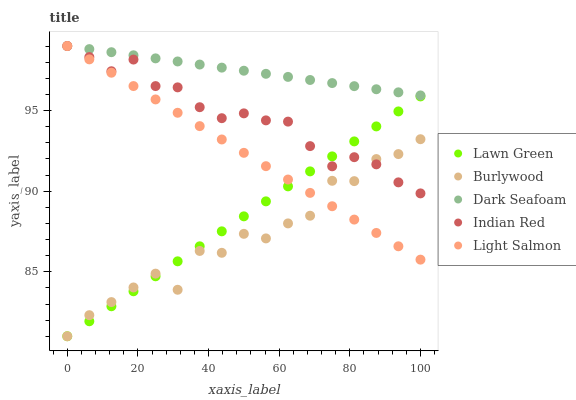Does Burlywood have the minimum area under the curve?
Answer yes or no. Yes. Does Dark Seafoam have the maximum area under the curve?
Answer yes or no. Yes. Does Lawn Green have the minimum area under the curve?
Answer yes or no. No. Does Lawn Green have the maximum area under the curve?
Answer yes or no. No. Is Dark Seafoam the smoothest?
Answer yes or no. Yes. Is Burlywood the roughest?
Answer yes or no. Yes. Is Lawn Green the smoothest?
Answer yes or no. No. Is Lawn Green the roughest?
Answer yes or no. No. Does Burlywood have the lowest value?
Answer yes or no. Yes. Does Dark Seafoam have the lowest value?
Answer yes or no. No. Does Indian Red have the highest value?
Answer yes or no. Yes. Does Lawn Green have the highest value?
Answer yes or no. No. Is Lawn Green less than Dark Seafoam?
Answer yes or no. Yes. Is Dark Seafoam greater than Burlywood?
Answer yes or no. Yes. Does Light Salmon intersect Indian Red?
Answer yes or no. Yes. Is Light Salmon less than Indian Red?
Answer yes or no. No. Is Light Salmon greater than Indian Red?
Answer yes or no. No. Does Lawn Green intersect Dark Seafoam?
Answer yes or no. No. 